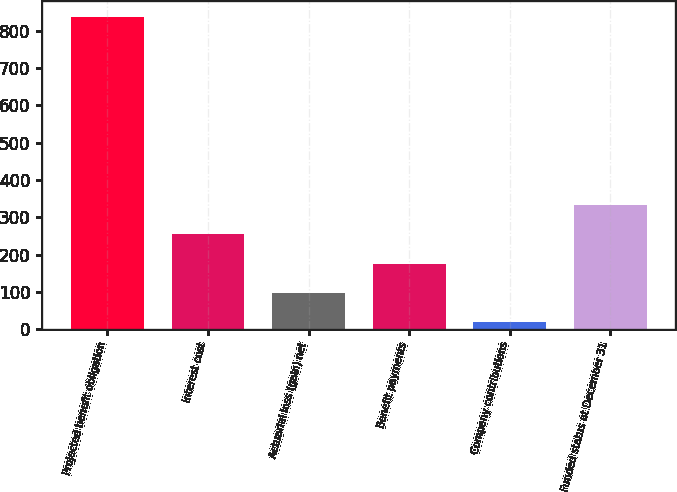<chart> <loc_0><loc_0><loc_500><loc_500><bar_chart><fcel>Projected benefit obligation<fcel>Interest cost<fcel>Actuarial loss (gain) net<fcel>Benefit payments<fcel>Company contributions<fcel>Funded status at December 31<nl><fcel>836.8<fcel>254.4<fcel>96.8<fcel>175.6<fcel>18<fcel>333.2<nl></chart> 